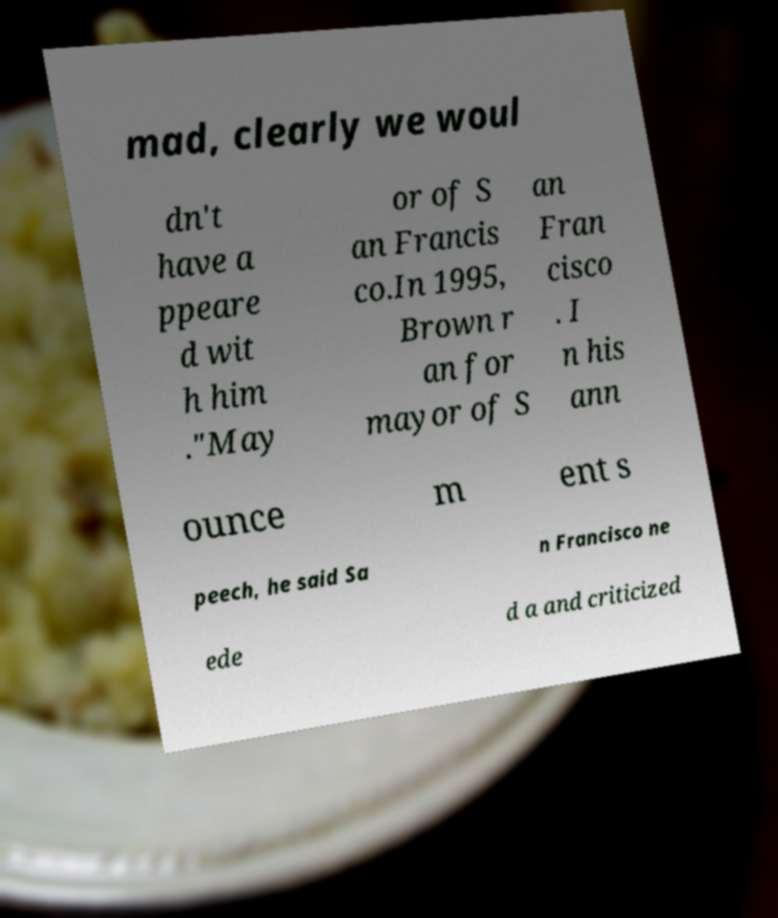Could you extract and type out the text from this image? mad, clearly we woul dn't have a ppeare d wit h him ."May or of S an Francis co.In 1995, Brown r an for mayor of S an Fran cisco . I n his ann ounce m ent s peech, he said Sa n Francisco ne ede d a and criticized 